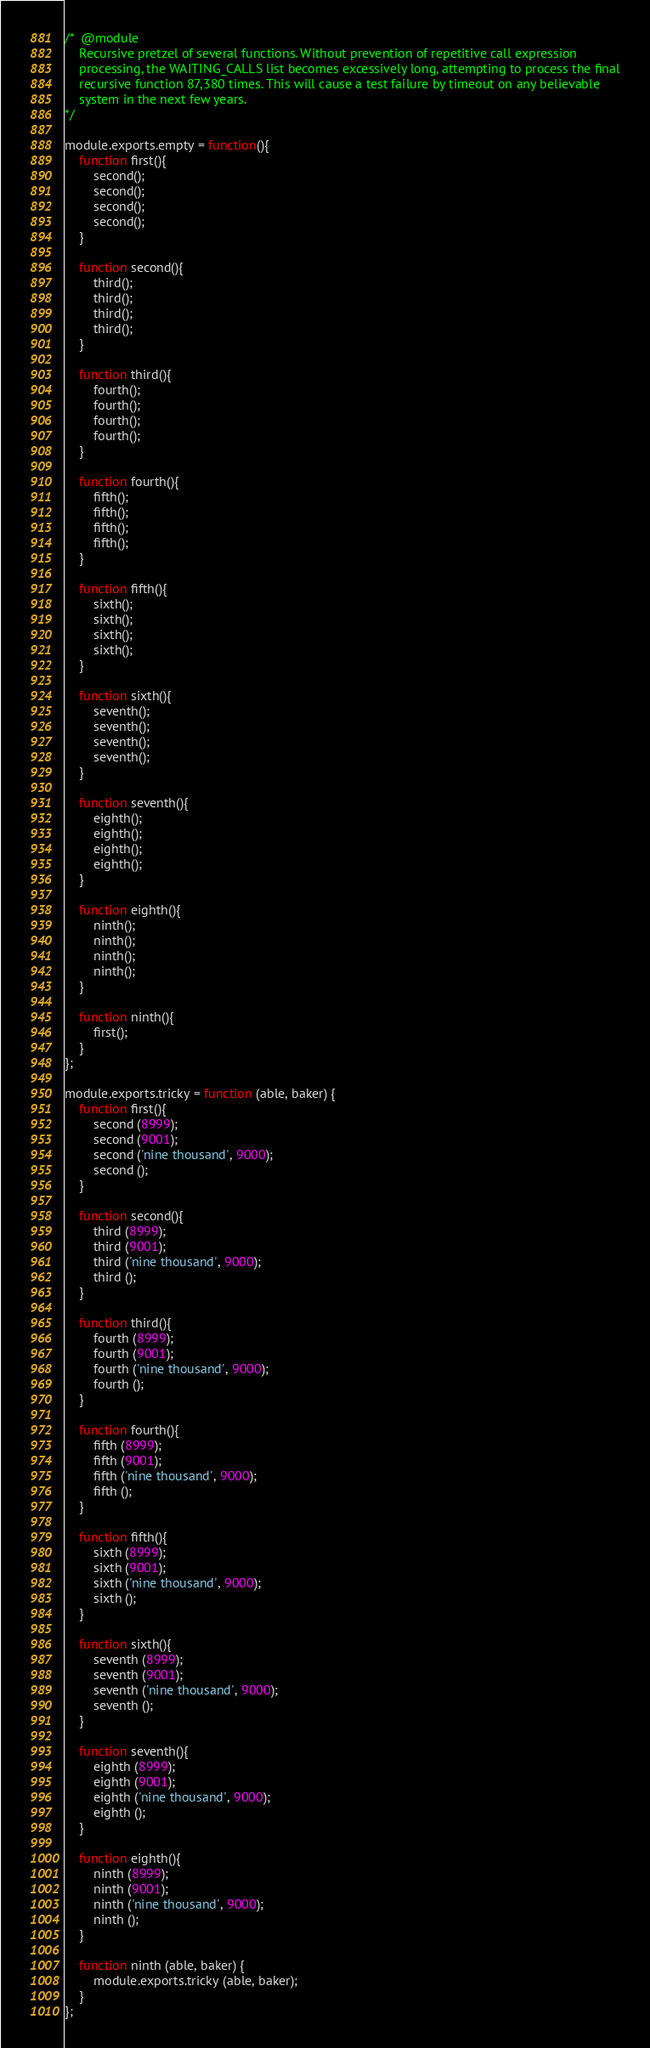Convert code to text. <code><loc_0><loc_0><loc_500><loc_500><_JavaScript_>
/*  @module
    Recursive pretzel of several functions. Without prevention of repetitive call expression
    processing, the WAITING_CALLS list becomes excessively long, attempting to process the final
    recursive function 87,380 times. This will cause a test failure by timeout on any believable
    system in the next few years.
*/

module.exports.empty = function(){
    function first(){
        second();
        second();
        second();
        second();
    }

    function second(){
        third();
        third();
        third();
        third();
    }

    function third(){
        fourth();
        fourth();
        fourth();
        fourth();
    }

    function fourth(){
        fifth();
        fifth();
        fifth();
        fifth();
    }

    function fifth(){
        sixth();
        sixth();
        sixth();
        sixth();
    }

    function sixth(){
        seventh();
        seventh();
        seventh();
        seventh();
    }

    function seventh(){
        eighth();
        eighth();
        eighth();
        eighth();
    }

    function eighth(){
        ninth();
        ninth();
        ninth();
        ninth();
    }

    function ninth(){
        first();
    }
};

module.exports.tricky = function (able, baker) {
    function first(){
        second (8999);
        second (9001);
        second ('nine thousand', 9000);
        second ();
    }

    function second(){
        third (8999);
        third (9001);
        third ('nine thousand', 9000);
        third ();
    }

    function third(){
        fourth (8999);
        fourth (9001);
        fourth ('nine thousand', 9000);
        fourth ();
    }

    function fourth(){
        fifth (8999);
        fifth (9001);
        fifth ('nine thousand', 9000);
        fifth ();
    }

    function fifth(){
        sixth (8999);
        sixth (9001);
        sixth ('nine thousand', 9000);
        sixth ();
    }

    function sixth(){
        seventh (8999);
        seventh (9001);
        seventh ('nine thousand', 9000);
        seventh ();
    }

    function seventh(){
        eighth (8999);
        eighth (9001);
        eighth ('nine thousand', 9000);
        eighth ();
    }

    function eighth(){
        ninth (8999);
        ninth (9001);
        ninth ('nine thousand', 9000);
        ninth ();
    }

    function ninth (able, baker) {
        module.exports.tricky (able, baker);
    }
};
</code> 